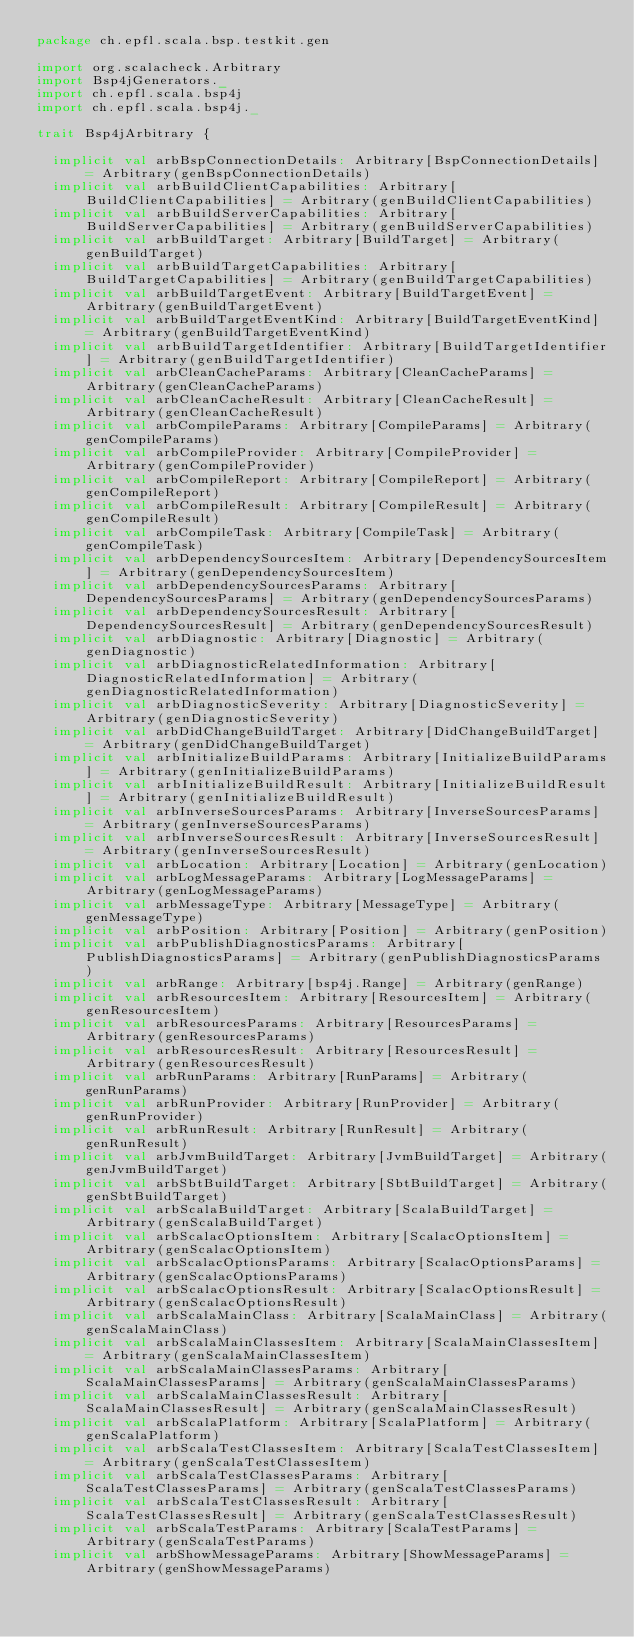<code> <loc_0><loc_0><loc_500><loc_500><_Scala_>package ch.epfl.scala.bsp.testkit.gen

import org.scalacheck.Arbitrary
import Bsp4jGenerators._
import ch.epfl.scala.bsp4j
import ch.epfl.scala.bsp4j._

trait Bsp4jArbitrary {

  implicit val arbBspConnectionDetails: Arbitrary[BspConnectionDetails] = Arbitrary(genBspConnectionDetails)
  implicit val arbBuildClientCapabilities: Arbitrary[BuildClientCapabilities] = Arbitrary(genBuildClientCapabilities)
  implicit val arbBuildServerCapabilities: Arbitrary[BuildServerCapabilities] = Arbitrary(genBuildServerCapabilities)
  implicit val arbBuildTarget: Arbitrary[BuildTarget] = Arbitrary(genBuildTarget)
  implicit val arbBuildTargetCapabilities: Arbitrary[BuildTargetCapabilities] = Arbitrary(genBuildTargetCapabilities)
  implicit val arbBuildTargetEvent: Arbitrary[BuildTargetEvent] = Arbitrary(genBuildTargetEvent)
  implicit val arbBuildTargetEventKind: Arbitrary[BuildTargetEventKind] = Arbitrary(genBuildTargetEventKind)
  implicit val arbBuildTargetIdentifier: Arbitrary[BuildTargetIdentifier] = Arbitrary(genBuildTargetIdentifier)
  implicit val arbCleanCacheParams: Arbitrary[CleanCacheParams] = Arbitrary(genCleanCacheParams)
  implicit val arbCleanCacheResult: Arbitrary[CleanCacheResult] = Arbitrary(genCleanCacheResult)
  implicit val arbCompileParams: Arbitrary[CompileParams] = Arbitrary(genCompileParams)
  implicit val arbCompileProvider: Arbitrary[CompileProvider] = Arbitrary(genCompileProvider)
  implicit val arbCompileReport: Arbitrary[CompileReport] = Arbitrary(genCompileReport)
  implicit val arbCompileResult: Arbitrary[CompileResult] = Arbitrary(genCompileResult)
  implicit val arbCompileTask: Arbitrary[CompileTask] = Arbitrary(genCompileTask)
  implicit val arbDependencySourcesItem: Arbitrary[DependencySourcesItem] = Arbitrary(genDependencySourcesItem)
  implicit val arbDependencySourcesParams: Arbitrary[DependencySourcesParams] = Arbitrary(genDependencySourcesParams)
  implicit val arbDependencySourcesResult: Arbitrary[DependencySourcesResult] = Arbitrary(genDependencySourcesResult)
  implicit val arbDiagnostic: Arbitrary[Diagnostic] = Arbitrary(genDiagnostic)
  implicit val arbDiagnosticRelatedInformation: Arbitrary[DiagnosticRelatedInformation] = Arbitrary(genDiagnosticRelatedInformation)
  implicit val arbDiagnosticSeverity: Arbitrary[DiagnosticSeverity] = Arbitrary(genDiagnosticSeverity)
  implicit val arbDidChangeBuildTarget: Arbitrary[DidChangeBuildTarget] = Arbitrary(genDidChangeBuildTarget)
  implicit val arbInitializeBuildParams: Arbitrary[InitializeBuildParams] = Arbitrary(genInitializeBuildParams)
  implicit val arbInitializeBuildResult: Arbitrary[InitializeBuildResult] = Arbitrary(genInitializeBuildResult)
  implicit val arbInverseSourcesParams: Arbitrary[InverseSourcesParams] = Arbitrary(genInverseSourcesParams)
  implicit val arbInverseSourcesResult: Arbitrary[InverseSourcesResult] = Arbitrary(genInverseSourcesResult)
  implicit val arbLocation: Arbitrary[Location] = Arbitrary(genLocation)
  implicit val arbLogMessageParams: Arbitrary[LogMessageParams] = Arbitrary(genLogMessageParams)
  implicit val arbMessageType: Arbitrary[MessageType] = Arbitrary(genMessageType)
  implicit val arbPosition: Arbitrary[Position] = Arbitrary(genPosition)
  implicit val arbPublishDiagnosticsParams: Arbitrary[PublishDiagnosticsParams] = Arbitrary(genPublishDiagnosticsParams)
  implicit val arbRange: Arbitrary[bsp4j.Range] = Arbitrary(genRange)
  implicit val arbResourcesItem: Arbitrary[ResourcesItem] = Arbitrary(genResourcesItem)
  implicit val arbResourcesParams: Arbitrary[ResourcesParams] = Arbitrary(genResourcesParams)
  implicit val arbResourcesResult: Arbitrary[ResourcesResult] = Arbitrary(genResourcesResult)
  implicit val arbRunParams: Arbitrary[RunParams] = Arbitrary(genRunParams)
  implicit val arbRunProvider: Arbitrary[RunProvider] = Arbitrary(genRunProvider)
  implicit val arbRunResult: Arbitrary[RunResult] = Arbitrary(genRunResult)
  implicit val arbJvmBuildTarget: Arbitrary[JvmBuildTarget] = Arbitrary(genJvmBuildTarget)
  implicit val arbSbtBuildTarget: Arbitrary[SbtBuildTarget] = Arbitrary(genSbtBuildTarget)
  implicit val arbScalaBuildTarget: Arbitrary[ScalaBuildTarget] = Arbitrary(genScalaBuildTarget)
  implicit val arbScalacOptionsItem: Arbitrary[ScalacOptionsItem] = Arbitrary(genScalacOptionsItem)
  implicit val arbScalacOptionsParams: Arbitrary[ScalacOptionsParams] = Arbitrary(genScalacOptionsParams)
  implicit val arbScalacOptionsResult: Arbitrary[ScalacOptionsResult] = Arbitrary(genScalacOptionsResult)
  implicit val arbScalaMainClass: Arbitrary[ScalaMainClass] = Arbitrary(genScalaMainClass)
  implicit val arbScalaMainClassesItem: Arbitrary[ScalaMainClassesItem] = Arbitrary(genScalaMainClassesItem)
  implicit val arbScalaMainClassesParams: Arbitrary[ScalaMainClassesParams] = Arbitrary(genScalaMainClassesParams)
  implicit val arbScalaMainClassesResult: Arbitrary[ScalaMainClassesResult] = Arbitrary(genScalaMainClassesResult)
  implicit val arbScalaPlatform: Arbitrary[ScalaPlatform] = Arbitrary(genScalaPlatform)
  implicit val arbScalaTestClassesItem: Arbitrary[ScalaTestClassesItem] = Arbitrary(genScalaTestClassesItem)
  implicit val arbScalaTestClassesParams: Arbitrary[ScalaTestClassesParams] = Arbitrary(genScalaTestClassesParams)
  implicit val arbScalaTestClassesResult: Arbitrary[ScalaTestClassesResult] = Arbitrary(genScalaTestClassesResult)
  implicit val arbScalaTestParams: Arbitrary[ScalaTestParams] = Arbitrary(genScalaTestParams)
  implicit val arbShowMessageParams: Arbitrary[ShowMessageParams] = Arbitrary(genShowMessageParams)</code> 